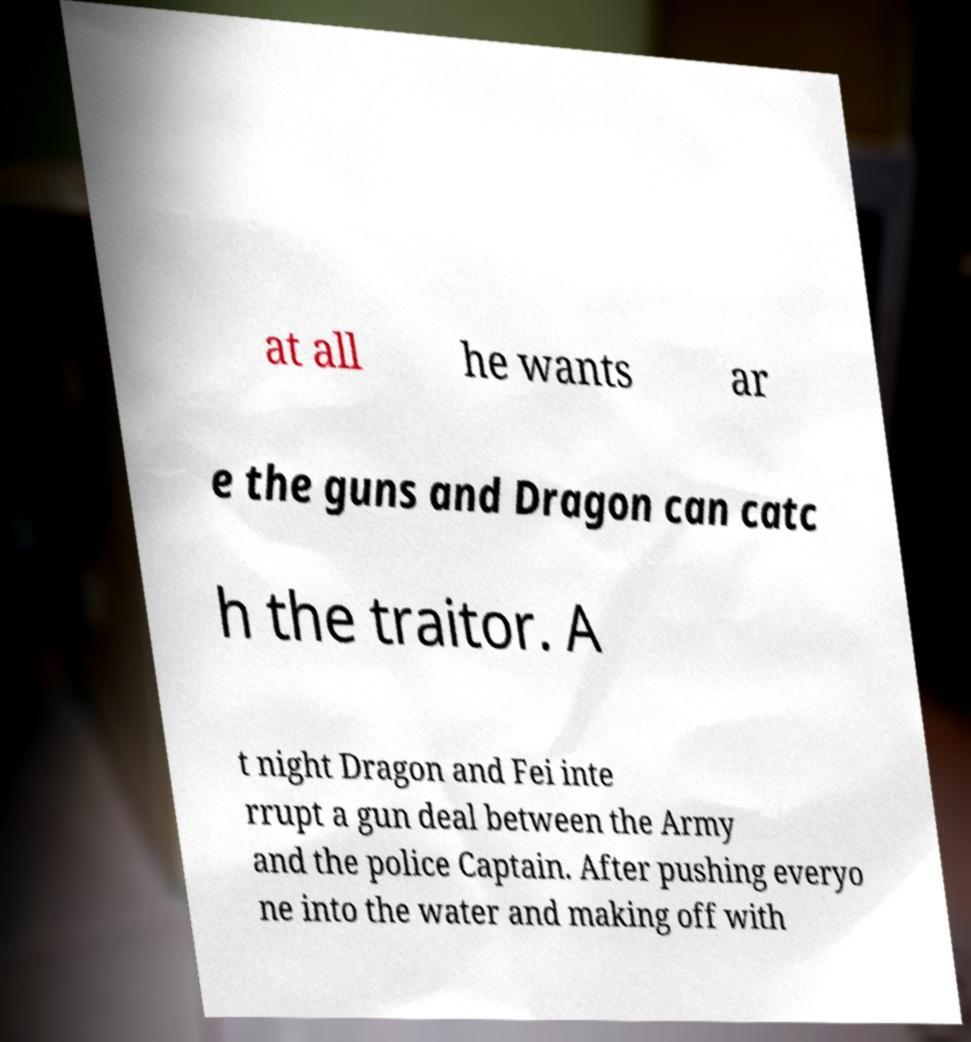Could you extract and type out the text from this image? at all he wants ar e the guns and Dragon can catc h the traitor. A t night Dragon and Fei inte rrupt a gun deal between the Army and the police Captain. After pushing everyo ne into the water and making off with 